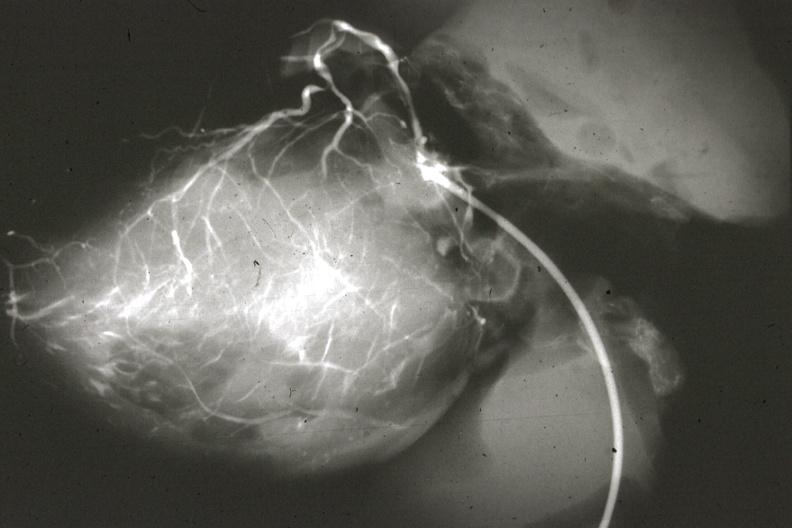s anomalous origin present?
Answer the question using a single word or phrase. No 